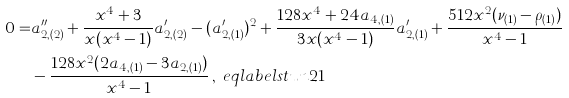<formula> <loc_0><loc_0><loc_500><loc_500>0 = & a _ { 2 , ( 2 ) } ^ { \prime \prime } + \frac { x ^ { 4 } + 3 } { x ( x ^ { 4 } - 1 ) } a _ { 2 , ( 2 ) } ^ { \prime } - ( a _ { 2 , ( 1 ) } ^ { \prime } ) ^ { 2 } + \frac { 1 2 8 x ^ { 4 } + 2 4 a _ { 4 , ( 1 ) } } { 3 x ( x ^ { 4 } - 1 ) } a _ { 2 , ( 1 ) } ^ { \prime } + \frac { 5 1 2 x ^ { 2 } ( \nu _ { ( 1 ) } - \rho _ { ( 1 ) } ) } { x ^ { 4 } - 1 } \\ & - \frac { 1 2 8 x ^ { 2 } ( 2 a _ { 4 , ( 1 ) } - 3 a _ { 2 , ( 1 ) } ) } { x ^ { 4 } - 1 } \, , \ e q l a b e l { s t u n 2 1 }</formula> 